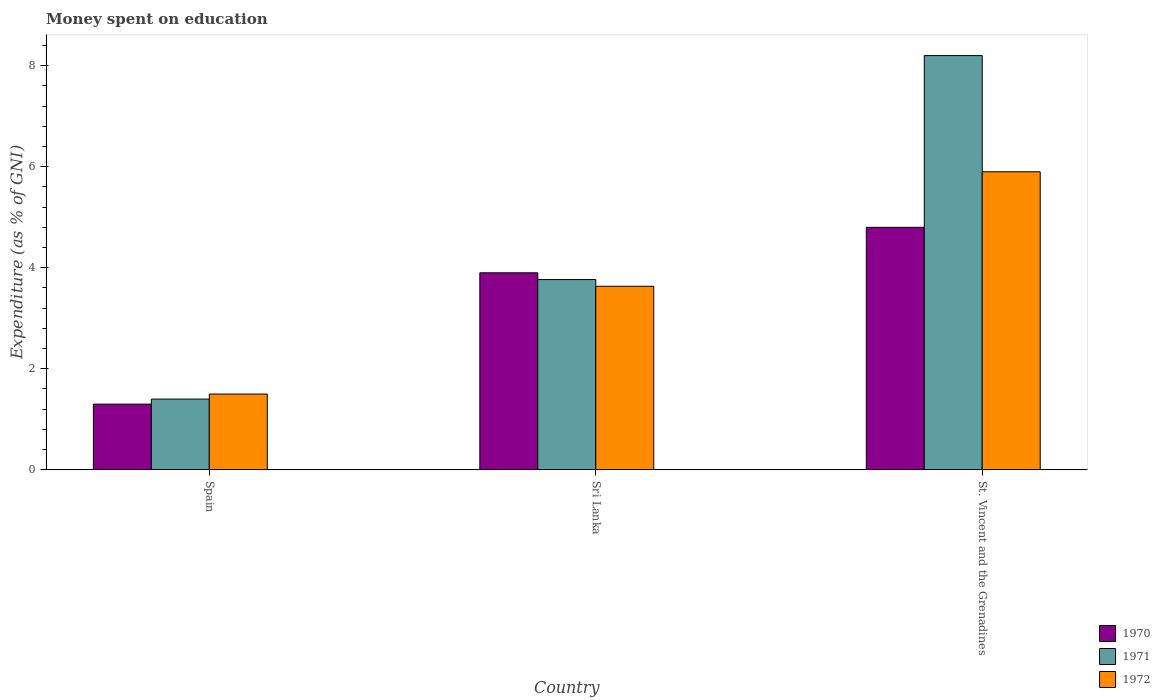How many different coloured bars are there?
Give a very brief answer. 3. How many groups of bars are there?
Make the answer very short. 3. Are the number of bars per tick equal to the number of legend labels?
Keep it short and to the point. Yes. Are the number of bars on each tick of the X-axis equal?
Provide a short and direct response. Yes. How many bars are there on the 1st tick from the left?
Ensure brevity in your answer.  3. How many bars are there on the 1st tick from the right?
Ensure brevity in your answer.  3. What is the label of the 1st group of bars from the left?
Keep it short and to the point. Spain. What is the amount of money spent on education in 1971 in Spain?
Provide a succinct answer. 1.4. In which country was the amount of money spent on education in 1972 maximum?
Your response must be concise. St. Vincent and the Grenadines. In which country was the amount of money spent on education in 1970 minimum?
Offer a very short reply. Spain. What is the difference between the amount of money spent on education in 1971 in Sri Lanka and that in St. Vincent and the Grenadines?
Offer a very short reply. -4.43. What is the difference between the amount of money spent on education in 1972 in Spain and the amount of money spent on education in 1970 in St. Vincent and the Grenadines?
Give a very brief answer. -3.3. What is the average amount of money spent on education in 1971 per country?
Your answer should be very brief. 4.46. What is the difference between the amount of money spent on education of/in 1972 and amount of money spent on education of/in 1970 in St. Vincent and the Grenadines?
Your answer should be compact. 1.1. In how many countries, is the amount of money spent on education in 1971 greater than 2.4 %?
Your response must be concise. 2. What is the ratio of the amount of money spent on education in 1971 in Spain to that in St. Vincent and the Grenadines?
Ensure brevity in your answer.  0.17. Is the amount of money spent on education in 1972 in Sri Lanka less than that in St. Vincent and the Grenadines?
Your answer should be very brief. Yes. What is the difference between the highest and the second highest amount of money spent on education in 1972?
Keep it short and to the point. -2.13. What is the difference between the highest and the lowest amount of money spent on education in 1970?
Your response must be concise. 3.5. Is the sum of the amount of money spent on education in 1972 in Sri Lanka and St. Vincent and the Grenadines greater than the maximum amount of money spent on education in 1970 across all countries?
Offer a terse response. Yes. What does the 3rd bar from the left in Spain represents?
Make the answer very short. 1972. Is it the case that in every country, the sum of the amount of money spent on education in 1971 and amount of money spent on education in 1970 is greater than the amount of money spent on education in 1972?
Provide a short and direct response. Yes. How many bars are there?
Your answer should be very brief. 9. Are the values on the major ticks of Y-axis written in scientific E-notation?
Ensure brevity in your answer.  No. How are the legend labels stacked?
Your answer should be compact. Vertical. What is the title of the graph?
Ensure brevity in your answer.  Money spent on education. Does "1986" appear as one of the legend labels in the graph?
Make the answer very short. No. What is the label or title of the X-axis?
Ensure brevity in your answer.  Country. What is the label or title of the Y-axis?
Your answer should be very brief. Expenditure (as % of GNI). What is the Expenditure (as % of GNI) of 1971 in Spain?
Give a very brief answer. 1.4. What is the Expenditure (as % of GNI) in 1972 in Spain?
Give a very brief answer. 1.5. What is the Expenditure (as % of GNI) of 1970 in Sri Lanka?
Offer a terse response. 3.9. What is the Expenditure (as % of GNI) in 1971 in Sri Lanka?
Provide a succinct answer. 3.77. What is the Expenditure (as % of GNI) of 1972 in Sri Lanka?
Your response must be concise. 3.63. What is the Expenditure (as % of GNI) in 1970 in St. Vincent and the Grenadines?
Offer a very short reply. 4.8. What is the Expenditure (as % of GNI) of 1972 in St. Vincent and the Grenadines?
Provide a succinct answer. 5.9. Across all countries, what is the maximum Expenditure (as % of GNI) in 1970?
Provide a short and direct response. 4.8. Across all countries, what is the minimum Expenditure (as % of GNI) of 1971?
Give a very brief answer. 1.4. What is the total Expenditure (as % of GNI) in 1970 in the graph?
Keep it short and to the point. 10. What is the total Expenditure (as % of GNI) in 1971 in the graph?
Give a very brief answer. 13.37. What is the total Expenditure (as % of GNI) of 1972 in the graph?
Make the answer very short. 11.03. What is the difference between the Expenditure (as % of GNI) in 1971 in Spain and that in Sri Lanka?
Offer a very short reply. -2.37. What is the difference between the Expenditure (as % of GNI) in 1972 in Spain and that in Sri Lanka?
Make the answer very short. -2.13. What is the difference between the Expenditure (as % of GNI) in 1971 in Spain and that in St. Vincent and the Grenadines?
Offer a very short reply. -6.8. What is the difference between the Expenditure (as % of GNI) of 1971 in Sri Lanka and that in St. Vincent and the Grenadines?
Provide a short and direct response. -4.43. What is the difference between the Expenditure (as % of GNI) of 1972 in Sri Lanka and that in St. Vincent and the Grenadines?
Offer a very short reply. -2.27. What is the difference between the Expenditure (as % of GNI) of 1970 in Spain and the Expenditure (as % of GNI) of 1971 in Sri Lanka?
Your response must be concise. -2.47. What is the difference between the Expenditure (as % of GNI) in 1970 in Spain and the Expenditure (as % of GNI) in 1972 in Sri Lanka?
Offer a very short reply. -2.33. What is the difference between the Expenditure (as % of GNI) of 1971 in Spain and the Expenditure (as % of GNI) of 1972 in Sri Lanka?
Offer a very short reply. -2.23. What is the difference between the Expenditure (as % of GNI) in 1970 in Spain and the Expenditure (as % of GNI) in 1972 in St. Vincent and the Grenadines?
Your answer should be compact. -4.6. What is the difference between the Expenditure (as % of GNI) of 1971 in Sri Lanka and the Expenditure (as % of GNI) of 1972 in St. Vincent and the Grenadines?
Your answer should be compact. -2.13. What is the average Expenditure (as % of GNI) of 1970 per country?
Keep it short and to the point. 3.33. What is the average Expenditure (as % of GNI) in 1971 per country?
Your answer should be very brief. 4.46. What is the average Expenditure (as % of GNI) of 1972 per country?
Provide a succinct answer. 3.68. What is the difference between the Expenditure (as % of GNI) in 1970 and Expenditure (as % of GNI) in 1971 in Spain?
Keep it short and to the point. -0.1. What is the difference between the Expenditure (as % of GNI) of 1971 and Expenditure (as % of GNI) of 1972 in Spain?
Your response must be concise. -0.1. What is the difference between the Expenditure (as % of GNI) in 1970 and Expenditure (as % of GNI) in 1971 in Sri Lanka?
Offer a terse response. 0.13. What is the difference between the Expenditure (as % of GNI) in 1970 and Expenditure (as % of GNI) in 1972 in Sri Lanka?
Provide a short and direct response. 0.27. What is the difference between the Expenditure (as % of GNI) in 1971 and Expenditure (as % of GNI) in 1972 in Sri Lanka?
Provide a succinct answer. 0.13. What is the difference between the Expenditure (as % of GNI) of 1971 and Expenditure (as % of GNI) of 1972 in St. Vincent and the Grenadines?
Ensure brevity in your answer.  2.3. What is the ratio of the Expenditure (as % of GNI) in 1970 in Spain to that in Sri Lanka?
Your response must be concise. 0.33. What is the ratio of the Expenditure (as % of GNI) in 1971 in Spain to that in Sri Lanka?
Provide a succinct answer. 0.37. What is the ratio of the Expenditure (as % of GNI) of 1972 in Spain to that in Sri Lanka?
Make the answer very short. 0.41. What is the ratio of the Expenditure (as % of GNI) of 1970 in Spain to that in St. Vincent and the Grenadines?
Give a very brief answer. 0.27. What is the ratio of the Expenditure (as % of GNI) in 1971 in Spain to that in St. Vincent and the Grenadines?
Give a very brief answer. 0.17. What is the ratio of the Expenditure (as % of GNI) in 1972 in Spain to that in St. Vincent and the Grenadines?
Your answer should be compact. 0.25. What is the ratio of the Expenditure (as % of GNI) in 1970 in Sri Lanka to that in St. Vincent and the Grenadines?
Keep it short and to the point. 0.81. What is the ratio of the Expenditure (as % of GNI) of 1971 in Sri Lanka to that in St. Vincent and the Grenadines?
Ensure brevity in your answer.  0.46. What is the ratio of the Expenditure (as % of GNI) in 1972 in Sri Lanka to that in St. Vincent and the Grenadines?
Give a very brief answer. 0.62. What is the difference between the highest and the second highest Expenditure (as % of GNI) in 1970?
Offer a terse response. 0.9. What is the difference between the highest and the second highest Expenditure (as % of GNI) in 1971?
Provide a succinct answer. 4.43. What is the difference between the highest and the second highest Expenditure (as % of GNI) in 1972?
Your answer should be compact. 2.27. What is the difference between the highest and the lowest Expenditure (as % of GNI) of 1970?
Your answer should be very brief. 3.5. 